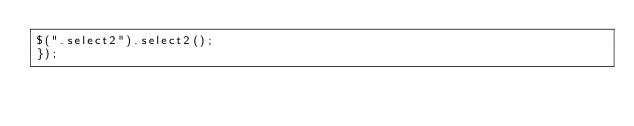<code> <loc_0><loc_0><loc_500><loc_500><_JavaScript_>$(".select2").select2();
});</code> 